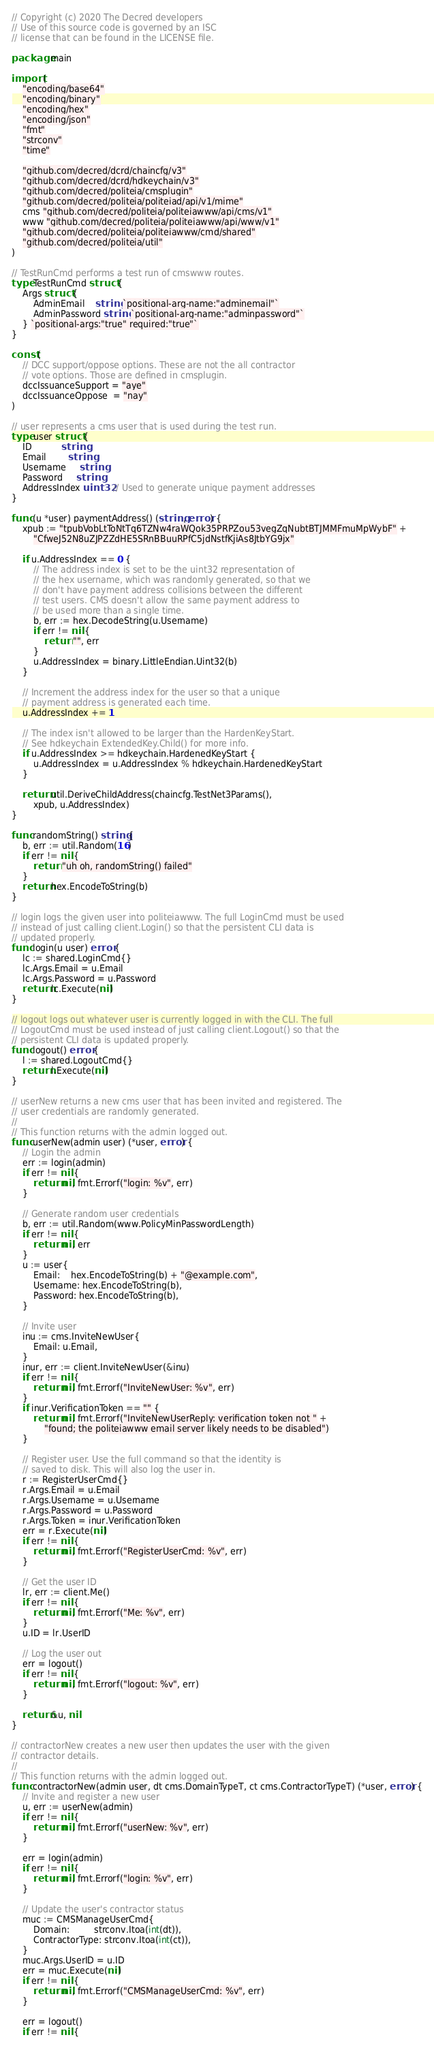Convert code to text. <code><loc_0><loc_0><loc_500><loc_500><_Go_>// Copyright (c) 2020 The Decred developers
// Use of this source code is governed by an ISC
// license that can be found in the LICENSE file.

package main

import (
	"encoding/base64"
	"encoding/binary"
	"encoding/hex"
	"encoding/json"
	"fmt"
	"strconv"
	"time"

	"github.com/decred/dcrd/chaincfg/v3"
	"github.com/decred/dcrd/hdkeychain/v3"
	"github.com/decred/politeia/cmsplugin"
	"github.com/decred/politeia/politeiad/api/v1/mime"
	cms "github.com/decred/politeia/politeiawww/api/cms/v1"
	www "github.com/decred/politeia/politeiawww/api/www/v1"
	"github.com/decred/politeia/politeiawww/cmd/shared"
	"github.com/decred/politeia/util"
)

// TestRunCmd performs a test run of cmswww routes.
type TestRunCmd struct {
	Args struct {
		AdminEmail    string `positional-arg-name:"adminemail"`
		AdminPassword string `positional-arg-name:"adminpassword"`
	} `positional-args:"true" required:"true"`
}

const (
	// DCC support/oppose options. These are not the all contractor
	// vote options. Those are defined in cmsplugin.
	dccIssuanceSupport = "aye"
	dccIssuanceOppose  = "nay"
)

// user represents a cms user that is used during the test run.
type user struct {
	ID           string
	Email        string
	Username     string
	Password     string
	AddressIndex uint32 // Used to generate unique payment addresses
}

func (u *user) paymentAddress() (string, error) {
	xpub := "tpubVobLtToNtTq6TZNw4raWQok35PRPZou53vegZqNubtBTJMMFmuMpWybF" +
		"CfweJ52N8uZJPZZdHE5SRnBBuuRPfC5jdNstfKjiAs8JtbYG9jx"

	if u.AddressIndex == 0 {
		// The address index is set to be the uint32 representation of
		// the hex username, which was randomly generated, so that we
		// don't have payment address collisions between the different
		// test users. CMS doesn't allow the same payment address to
		// be used more than a single time.
		b, err := hex.DecodeString(u.Username)
		if err != nil {
			return "", err
		}
		u.AddressIndex = binary.LittleEndian.Uint32(b)
	}

	// Increment the address index for the user so that a unique
	// payment address is generated each time.
	u.AddressIndex += 1

	// The index isn't allowed to be larger than the HardenKeyStart.
	// See hdkeychain ExtendedKey.Child() for more info.
	if u.AddressIndex >= hdkeychain.HardenedKeyStart {
		u.AddressIndex = u.AddressIndex % hdkeychain.HardenedKeyStart
	}

	return util.DeriveChildAddress(chaincfg.TestNet3Params(),
		xpub, u.AddressIndex)
}

func randomString() string {
	b, err := util.Random(16)
	if err != nil {
		return "uh oh, randomString() failed"
	}
	return hex.EncodeToString(b)
}

// login logs the given user into politeiawww. The full LoginCmd must be used
// instead of just calling client.Login() so that the persistent CLI data is
// updated properly.
func login(u user) error {
	lc := shared.LoginCmd{}
	lc.Args.Email = u.Email
	lc.Args.Password = u.Password
	return lc.Execute(nil)
}

// logout logs out whatever user is currently logged in with the CLI. The full
// LogoutCmd must be used instead of just calling client.Logout() so that the
// persistent CLI data is updated properly.
func logout() error {
	l := shared.LogoutCmd{}
	return l.Execute(nil)
}

// userNew returns a new cms user that has been invited and registered. The
// user credentials are randomly generated.
//
// This function returns with the admin logged out.
func userNew(admin user) (*user, error) {
	// Login the admin
	err := login(admin)
	if err != nil {
		return nil, fmt.Errorf("login: %v", err)
	}

	// Generate random user credentials
	b, err := util.Random(www.PolicyMinPasswordLength)
	if err != nil {
		return nil, err
	}
	u := user{
		Email:    hex.EncodeToString(b) + "@example.com",
		Username: hex.EncodeToString(b),
		Password: hex.EncodeToString(b),
	}

	// Invite user
	inu := cms.InviteNewUser{
		Email: u.Email,
	}
	inur, err := client.InviteNewUser(&inu)
	if err != nil {
		return nil, fmt.Errorf("InviteNewUser: %v", err)
	}
	if inur.VerificationToken == "" {
		return nil, fmt.Errorf("InviteNewUserReply: verification token not " +
			"found; the politeiawww email server likely needs to be disabled")
	}

	// Register user. Use the full command so that the identity is
	// saved to disk. This will also log the user in.
	r := RegisterUserCmd{}
	r.Args.Email = u.Email
	r.Args.Username = u.Username
	r.Args.Password = u.Password
	r.Args.Token = inur.VerificationToken
	err = r.Execute(nil)
	if err != nil {
		return nil, fmt.Errorf("RegisterUserCmd: %v", err)
	}

	// Get the user ID
	lr, err := client.Me()
	if err != nil {
		return nil, fmt.Errorf("Me: %v", err)
	}
	u.ID = lr.UserID

	// Log the user out
	err = logout()
	if err != nil {
		return nil, fmt.Errorf("logout: %v", err)
	}

	return &u, nil
}

// contractorNew creates a new user then updates the user with the given
// contractor details.
//
// This function returns with the admin logged out.
func contractorNew(admin user, dt cms.DomainTypeT, ct cms.ContractorTypeT) (*user, error) {
	// Invite and register a new user
	u, err := userNew(admin)
	if err != nil {
		return nil, fmt.Errorf("userNew: %v", err)
	}

	err = login(admin)
	if err != nil {
		return nil, fmt.Errorf("login: %v", err)
	}

	// Update the user's contractor status
	muc := CMSManageUserCmd{
		Domain:         strconv.Itoa(int(dt)),
		ContractorType: strconv.Itoa(int(ct)),
	}
	muc.Args.UserID = u.ID
	err = muc.Execute(nil)
	if err != nil {
		return nil, fmt.Errorf("CMSManageUserCmd: %v", err)
	}

	err = logout()
	if err != nil {</code> 